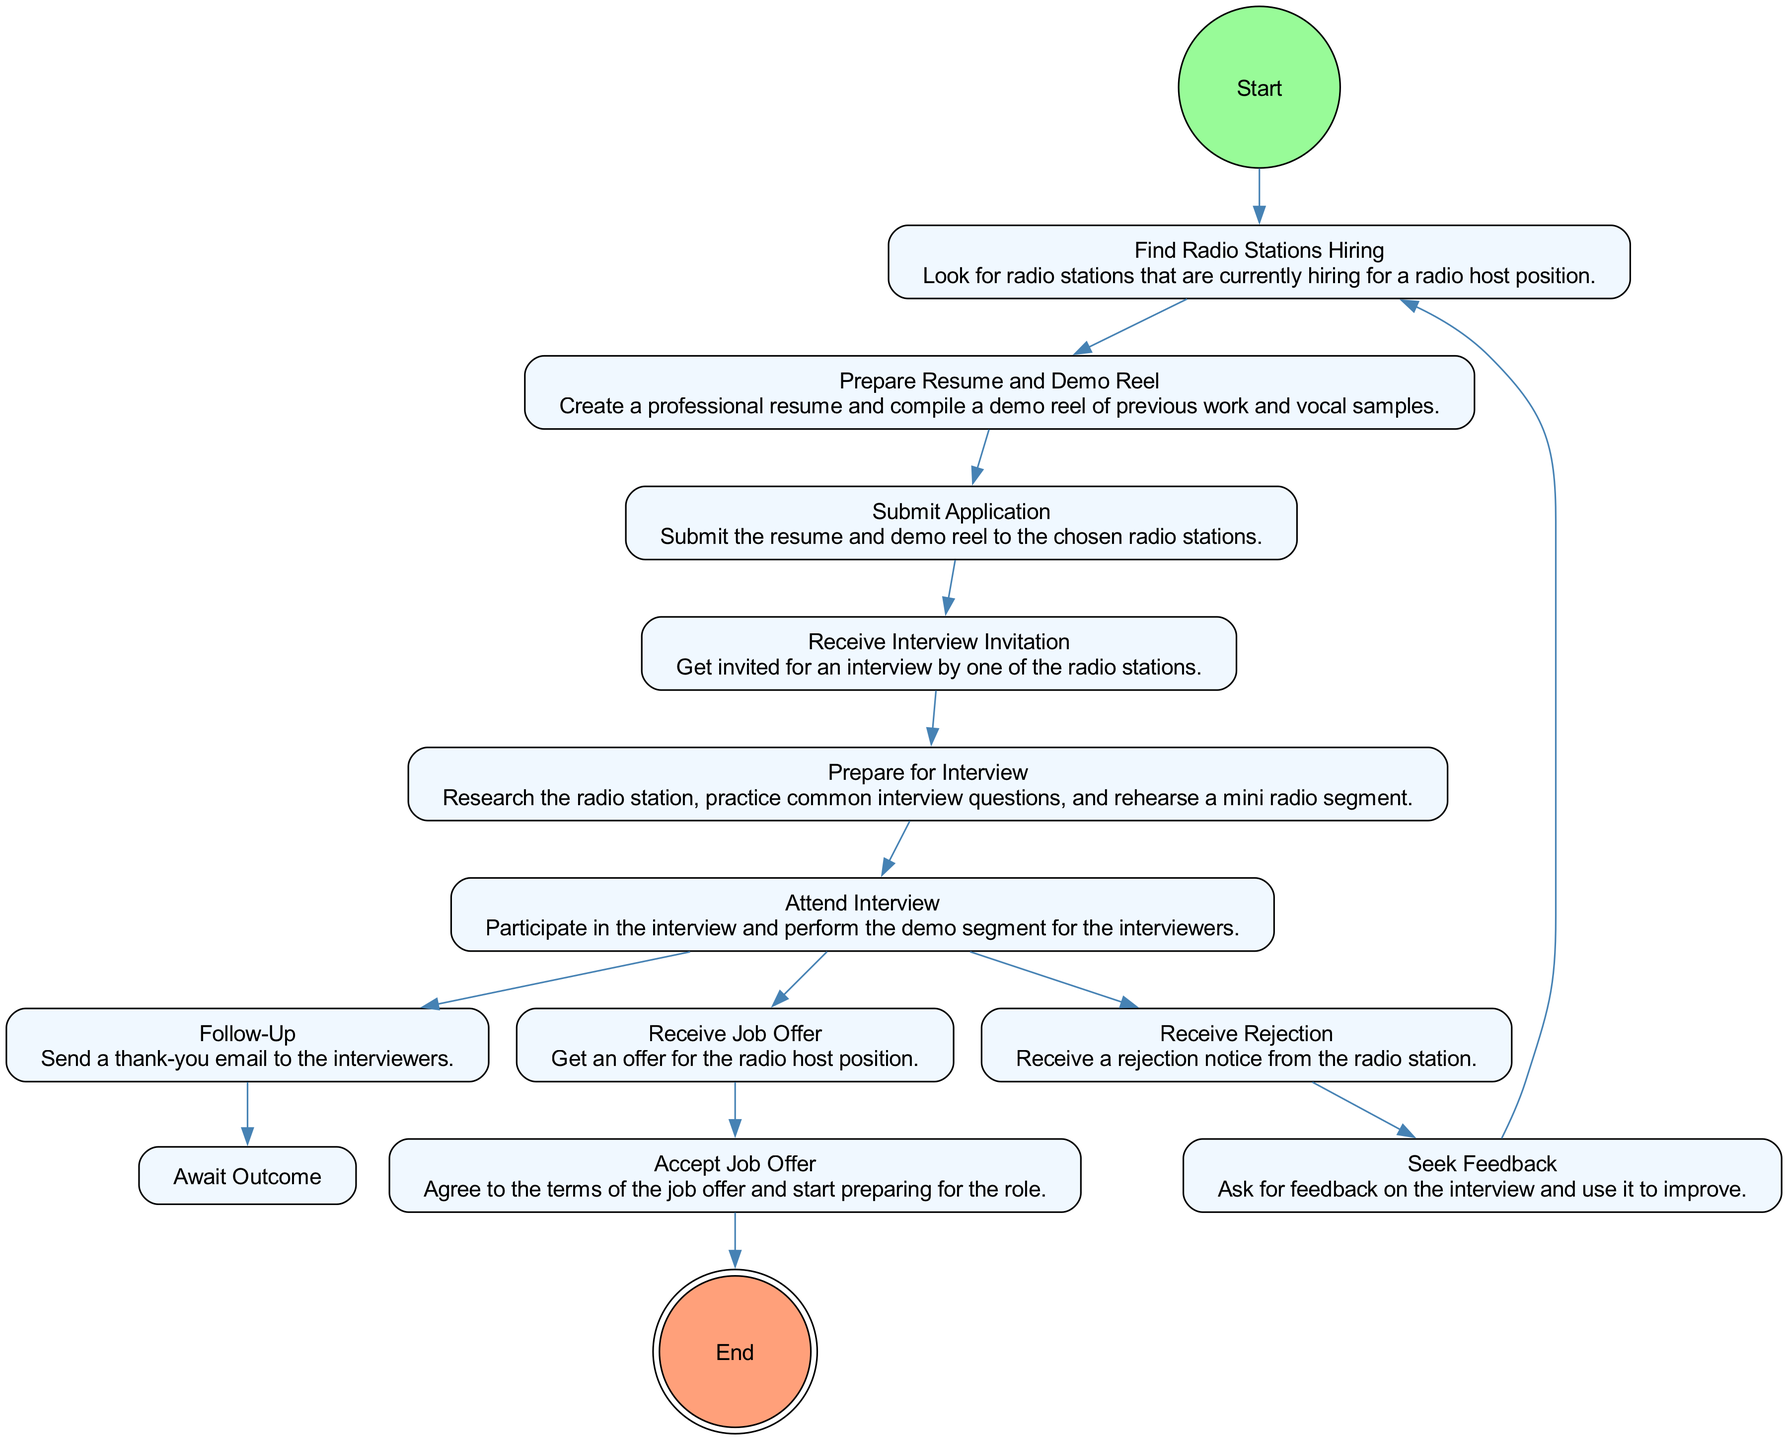What's the first activity in the diagram? The first activity in the diagram is labeled as "Find Radio Stations Hiring". It is the first node connected to the "Start" node.
Answer: Find Radio Stations Hiring How many main activities are there in total? By counting each unique activity node listed and recognizing that there are ten activities, we can conclude that the total number of main activities is ten.
Answer: 10 What do you do after receiving a job offer? According to the diagram, after receiving a job offer, the next step is to "Accept Job Offer". This indicates a direct flow from that activity.
Answer: Accept Job Offer What is the outcome of the "Attend Interview" activity? The "Attend Interview" activity leads to three possible outcomes, which are "Follow-Up", "Receive Job Offer", and "Receive Rejection". This branching signifies multiple potential results.
Answer: Follow-Up, Receive Job Offer, Receive Rejection What should you do if you receive a rejection? If you receive a rejection, the diagram indicates you should "Seek Feedback", which is the next activity connected to the rejection outcome.
Answer: Seek Feedback How do you move back to the beginning after seeking feedback? After completing the "Seek Feedback" activity, the flow returns to "Find Radio Stations Hiring", indicating a cyclical process where one can seek new opportunities after feedback.
Answer: Find Radio Stations Hiring What is the final activity before the end of the diagram? The last activity before reaching the end node is "Accept Job Offer", which directly links to the end of the procedure, indicating the conclusion of the auditioning process.
Answer: Accept Job Offer How does "Prepare Resume and Demo Reel" connect to the diagram? The "Prepare Resume and Demo Reel" activity directly succeeds "Find Radio Stations Hiring", indicating this is the next critical step in the audition journey.
Answer: Prepare Resume and Demo Reel Which activity follows "Follow-Up"? Following "Follow-Up", the next activity is "Await Outcome", demonstrating the continuation of the process after sending a thank-you email.
Answer: Await Outcome 